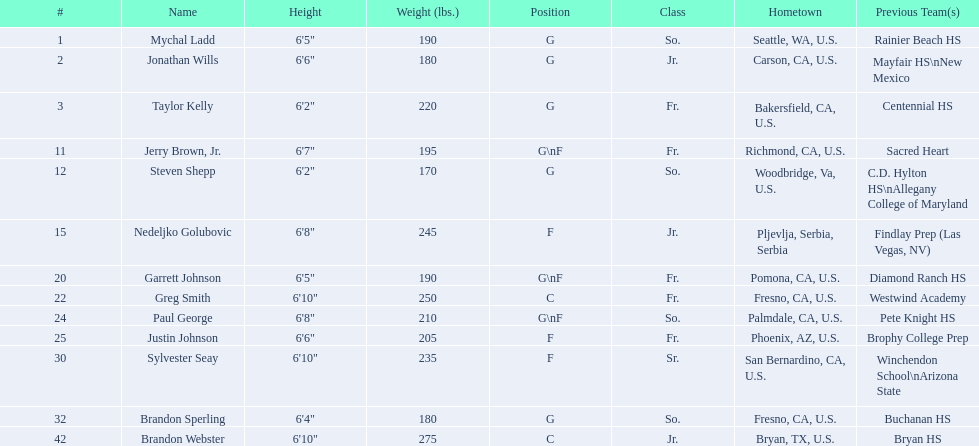Who are the players for the 2009-10 fresno state bulldogs men's basketball team? Mychal Ladd, Jonathan Wills, Taylor Kelly, Jerry Brown, Jr., Steven Shepp, Nedeljko Golubovic, Garrett Johnson, Greg Smith, Paul George, Justin Johnson, Sylvester Seay, Brandon Sperling, Brandon Webster. What are their heights? 6'5", 6'6", 6'2", 6'7", 6'2", 6'8", 6'5", 6'10", 6'8", 6'6", 6'10", 6'4", 6'10". What is the shortest height? 6'2", 6'2". What is the lowest weight? 6'2". Which player is it? Steven Shepp. What are the specified categories of the players? So., Jr., Fr., Fr., So., Jr., Fr., Fr., So., Fr., Sr., So., Jr. Which one of these is not from the us? Jr. To which moniker does that item relate to? Nedeljko Golubovic. 